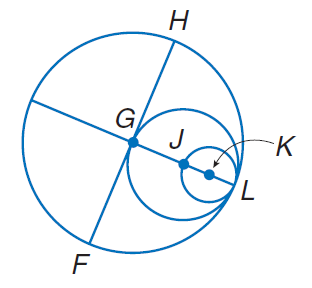Answer the mathemtical geometry problem and directly provide the correct option letter.
Question: Circles G, J, and K all intersect at L. If G H = 10, find G L.
Choices: A: 10 B: 20 C: 25 D: 35 A 